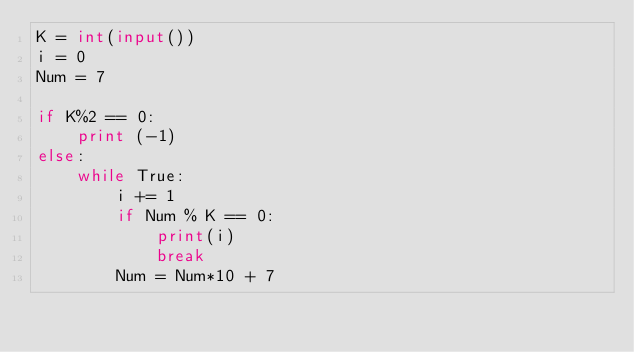<code> <loc_0><loc_0><loc_500><loc_500><_Python_>K = int(input())
i = 0
Num = 7

if K%2 == 0:
    print (-1)
else:
    while True:
        i += 1
        if Num % K == 0:
            print(i)
            break
        Num = Num*10 + 7
        
</code> 